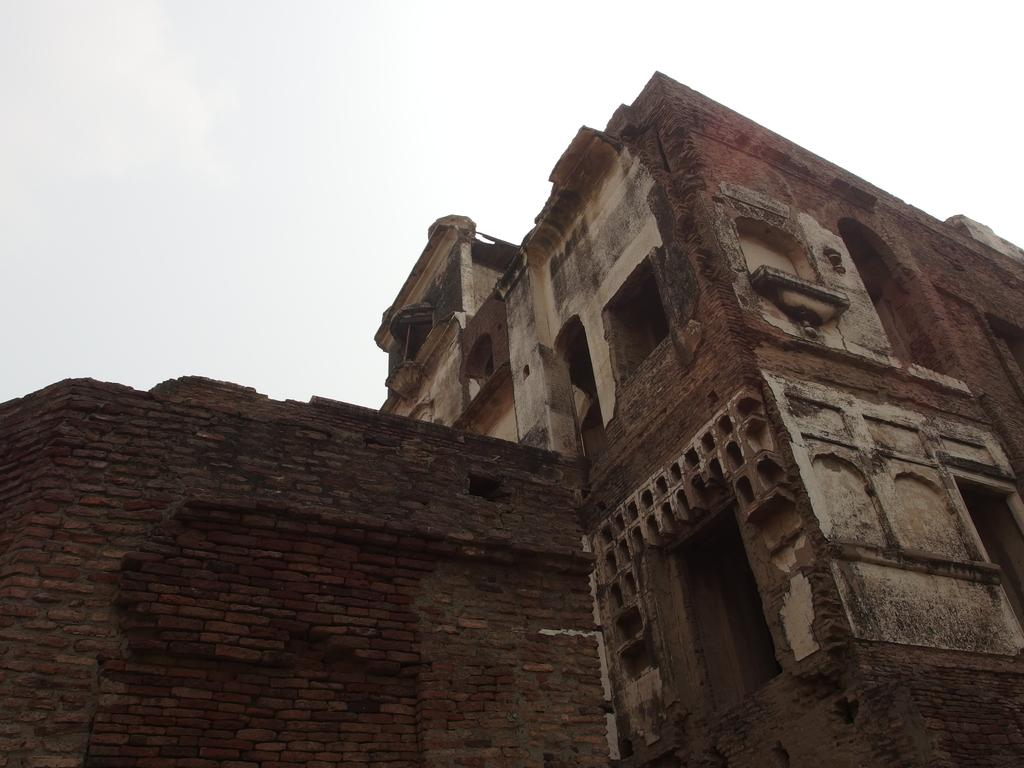What type of structure is located on the right side of the image? There is an old building on the right side of the image. What can be seen on the left side of the image? There is a wall on the left side of the image. Can you describe the positioning of the old building and the wall in the image? The old building is on the right side of the image, while the wall is on the left side. What type of grape can be seen growing on the old building in the image? There are no grapes present in the image, and the old building does not have any visible plants growing on it. 